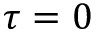<formula> <loc_0><loc_0><loc_500><loc_500>\tau = 0</formula> 